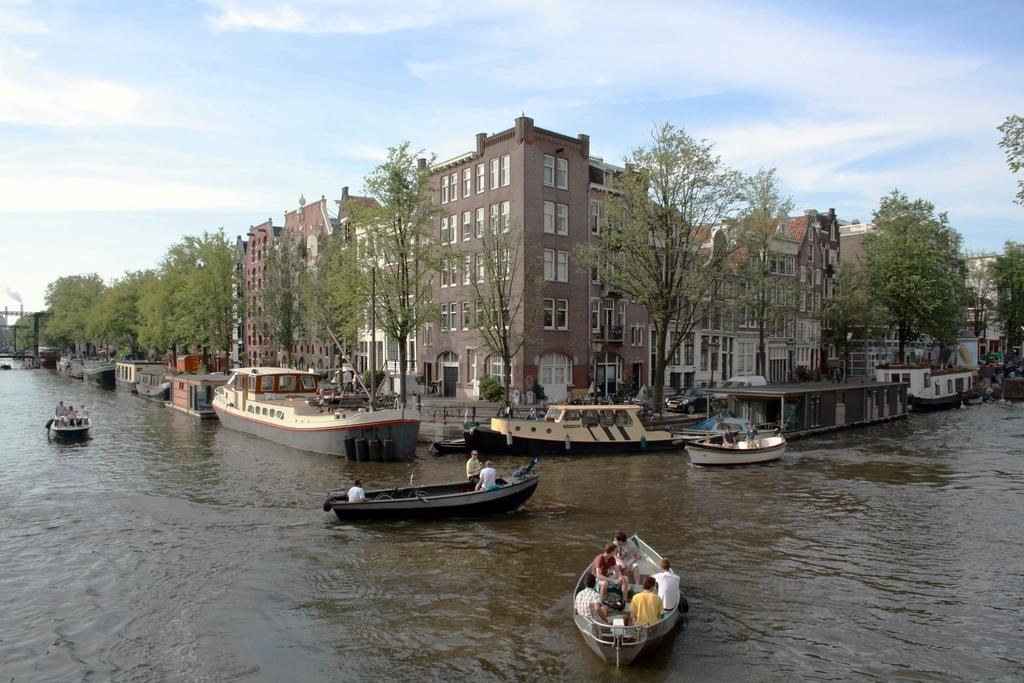What are the people in the image doing? The people in the image are on the boats. What can be seen in the background of the image? There are trees, buildings, and poles in the background of the image. What is visible at the bottom of the image? There is water visible at the bottom of the image. What is visible at the top of the image? There is sky visible at the top of the image. What decision did the unit make in the image? There is no mention of a unit or decision in the image; it features people on boats with a background of trees, buildings, and poles, as well as water and sky. 